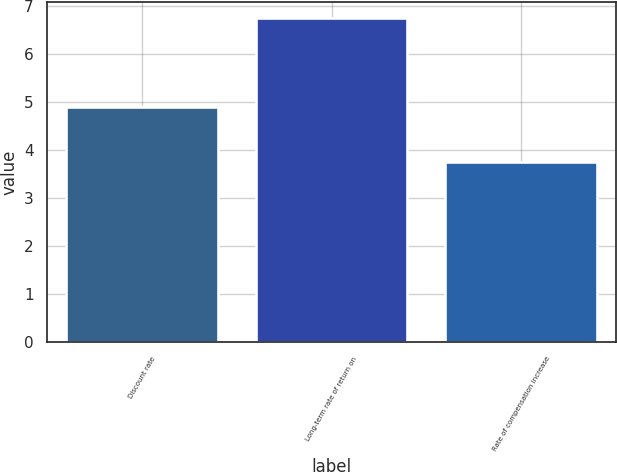Convert chart to OTSL. <chart><loc_0><loc_0><loc_500><loc_500><bar_chart><fcel>Discount rate<fcel>Long-term rate of return on<fcel>Rate of compensation increase<nl><fcel>4.9<fcel>6.75<fcel>3.75<nl></chart> 